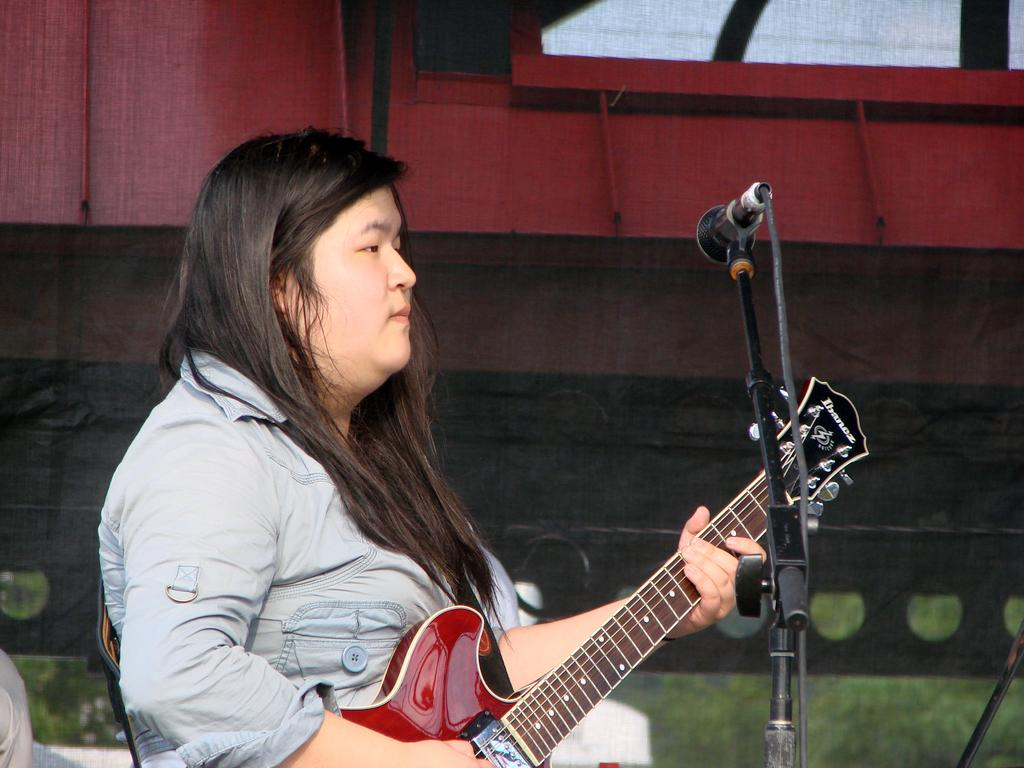What is the woman in the image doing? The woman is playing the guitar. What object is in front of the woman? There is a microphone in front of the woman. What is the color of the stage in the image? The stage is red. What type of land can be seen in the image? The land is grassy. How many breaths can be heard coming from the woman's arm in the image? There is no indication of breaths or any sound in the image, and the woman's arm is not mentioned as a focus. --- Facts: 1. There is a cat in the image. 2. The cat is sitting on a chair. 3. The chair has a patterned fabric. 4. There is a window in the background. 5. The window has curtains. Absurd Topics: bicycle, ocean, volcano Conversation: What animal is in the image? There is a cat in the image. What is the cat sitting on? The cat is sitting on a chair. Can you describe the chair's fabric? The chair has a patterned fabric. What is visible in the background of the image? There is a window in the background. How are the curtains associated with the window? The window has curtains. Reasoning: Let's think step by step in order to produce the conversation. We start by identifying the main subject in the image, which is the cat. Then, we describe what the cat is doing, which is sitting on a chair. Next, we mention the chair's fabric, which is patterned. We then describe the background, which includes a window. Finally, we identify the presence of curtains associated with the window. Absurd Question/Answer: Can you see any bicycles or oceans in the image? No, there are no bicycles or oceans present in the image. 